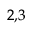Convert formula to latex. <formula><loc_0><loc_0><loc_500><loc_500>^ { 2 , 3 }</formula> 